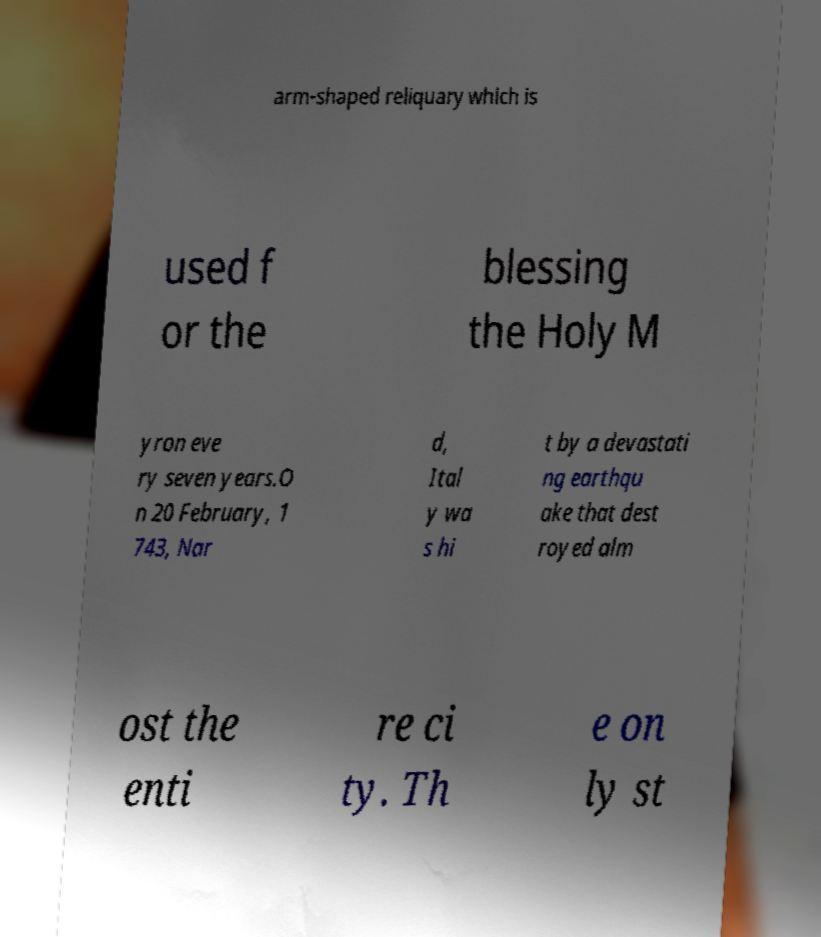Could you assist in decoding the text presented in this image and type it out clearly? arm-shaped reliquary which is used f or the blessing the Holy M yron eve ry seven years.O n 20 February, 1 743, Nar d, Ital y wa s hi t by a devastati ng earthqu ake that dest royed alm ost the enti re ci ty. Th e on ly st 